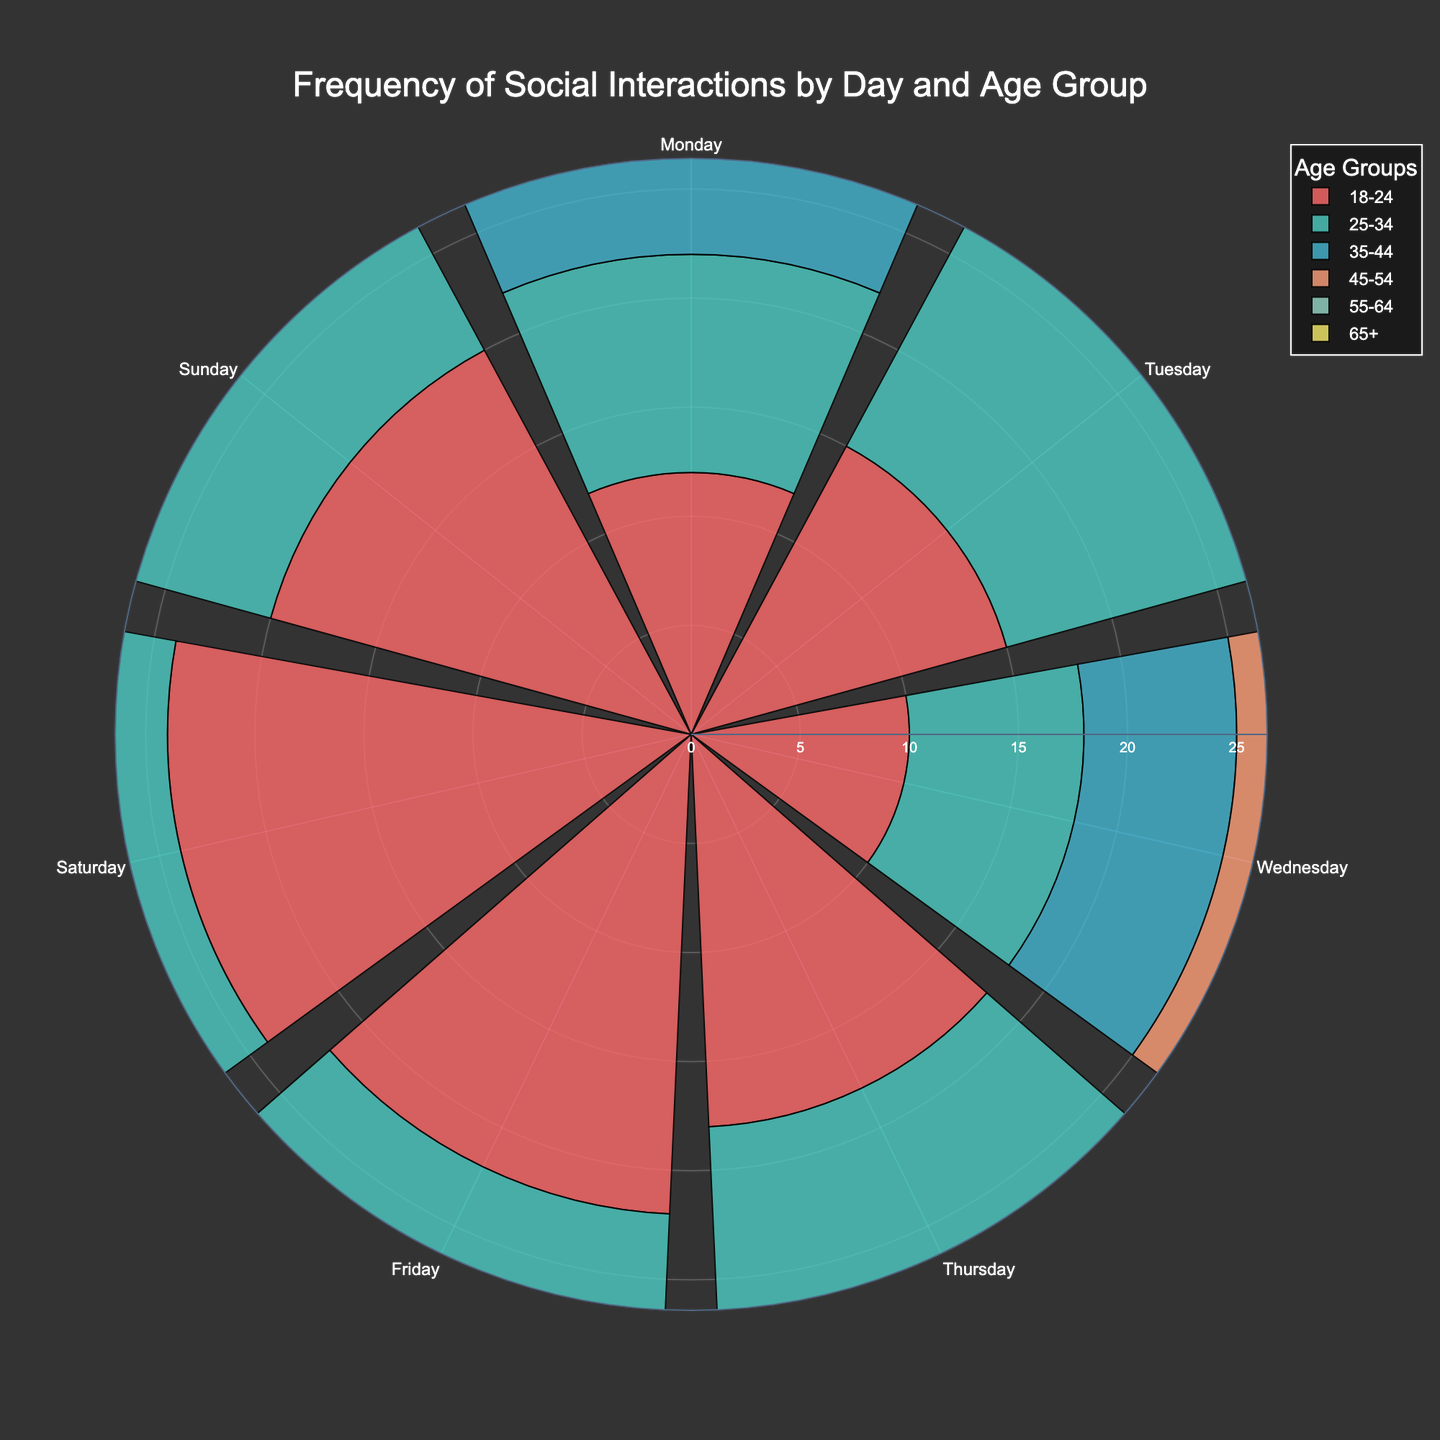What is the title of the rose chart? The title is usually at the top of the chart and is clearly indicated in the layout setup. For this chart, it specifies the subject of visualization.
Answer: "Frequency of Social Interactions by Day and Age Group" What is the color of the bars representing the 18-24 age group? The colors used in the chart are specified in a palette, and the first color listed is associated with the 18-24 age group.
Answer: Red (#FF6B6B) On which day of the week do 18-24-year-olds have the highest frequency of social interactions? To answer this, we look at the length of the bars for the 18-24 age group and identify which day has the longest bar.
Answer: Saturday Which age group has the lowest frequency of social interactions on most days? By comparing the lengths of the bars for each age group across all days, we can see which age group consistently has shorter bars.
Answer: 65+ How does the frequency of social interactions on Tuesday compare between the 25-34 and 35-44 age groups? We compare the bar lengths for Tuesday from both the 25-34 and 35-44 age groups. The 25-34 age group has a longer bar.
Answer: Higher for 25-34 What is the total frequency of social interactions for the 18-24 age group throughout the week? Summing the frequencies for each day in the 18-24 age group: 12 + 15 + 10 + 18 + 22 + 24 + 20.
Answer: 121 What is the average frequency of social interactions for the 45-54 age group from Monday to Friday? Sum the values for Monday to Friday and then divide by 5: (5 + 7 + 4 + 8 + 11) / 5.
Answer: 7 Which day has the most significant difference in social interactions between the youngest (18-24) and oldest (65+) age groups? Calculate the differences for each day and identify the maximum: (12-3, 15-4, 10-2, 18-4, 22-6, 24-8, 20-6), the largest difference is on Saturday.
Answer: Saturday What trend is observed in social interactions for the 55-64 age group over the week? Looking at the bar lengths for the 55-64 age group from Monday to Sunday, we observe a gradual increase, peaking on Saturday, then slightly decreasing on Sunday.
Answer: Increasing, peaks on Saturday Which age group shows the most significant drop in social interactions from Friday to Sunday? Compare the values for Friday and Sunday for each age group, and then calculate the drops to find the highest drop: 18-24 (22-20=2), 25-34 (18-15=3), 35-44 (15-13=2), 45-54 (11-10=1), 55-64 (9-8=1), 65+ (6-6=0).
Answer: 25-34 with a drop of 3 